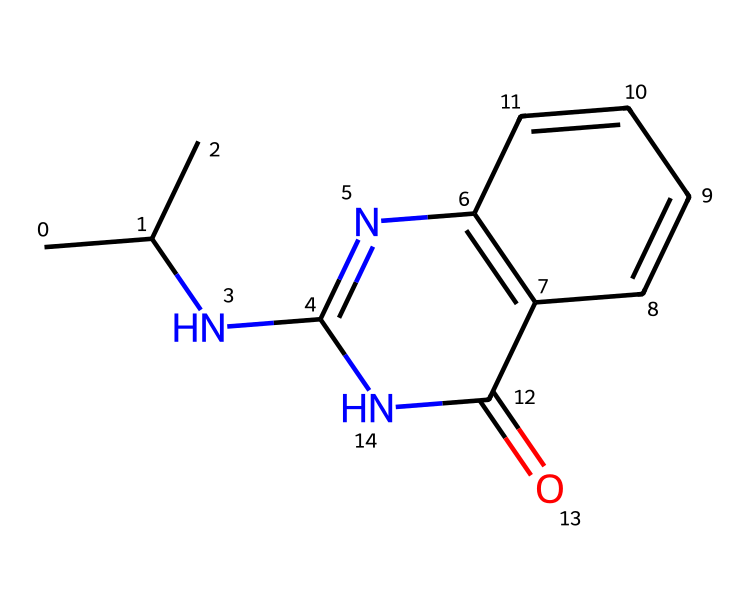How many nitrogen atoms are in this chemical? The SMILES representation CC(C)NC1=NC2=C(C=CC=C2)C(=O)N1 contains two nitrogen symbols (N), indicating that there are two nitrogen atoms present in the molecule.
Answer: two What type of chemical structure is represented here? The presence of the NC (nitrogen-containing) structure and aromatic rings (indicated by the C=CC=C pattern) suggests that this chemical is an aromatic amine known as a drug.
Answer: drug Does this chemical contain any carbonyl groups? The presence of the C(=O) in the structure indicates that there is a carbonyl group (C=O), confirming that this chemical does contain a carbonyl group.
Answer: yes What is the total number of rings in this chemical structure? The SMILES notation shows two different rings (one indicated by C1=NC and another by C2=C) which confirms that there are two distinct rings in the structure.
Answer: two What functional group is suggested by the nitrogen atom in this drug? The nitrogen atom (N) in the structure implies the presence of an amine functional group. Amines are common in performance-enhancing drugs to affect various biological processes.
Answer: amine What type of activity might this drug structure suggest based on its composition? Given that the structure is a performance-enhancing drug with a specific arrangement of nitrogen and carbon rings, it suggests effects on central nervous system functions such as stimulatory effects, commonly seen with certain performance enhancers.
Answer: stimulatory 